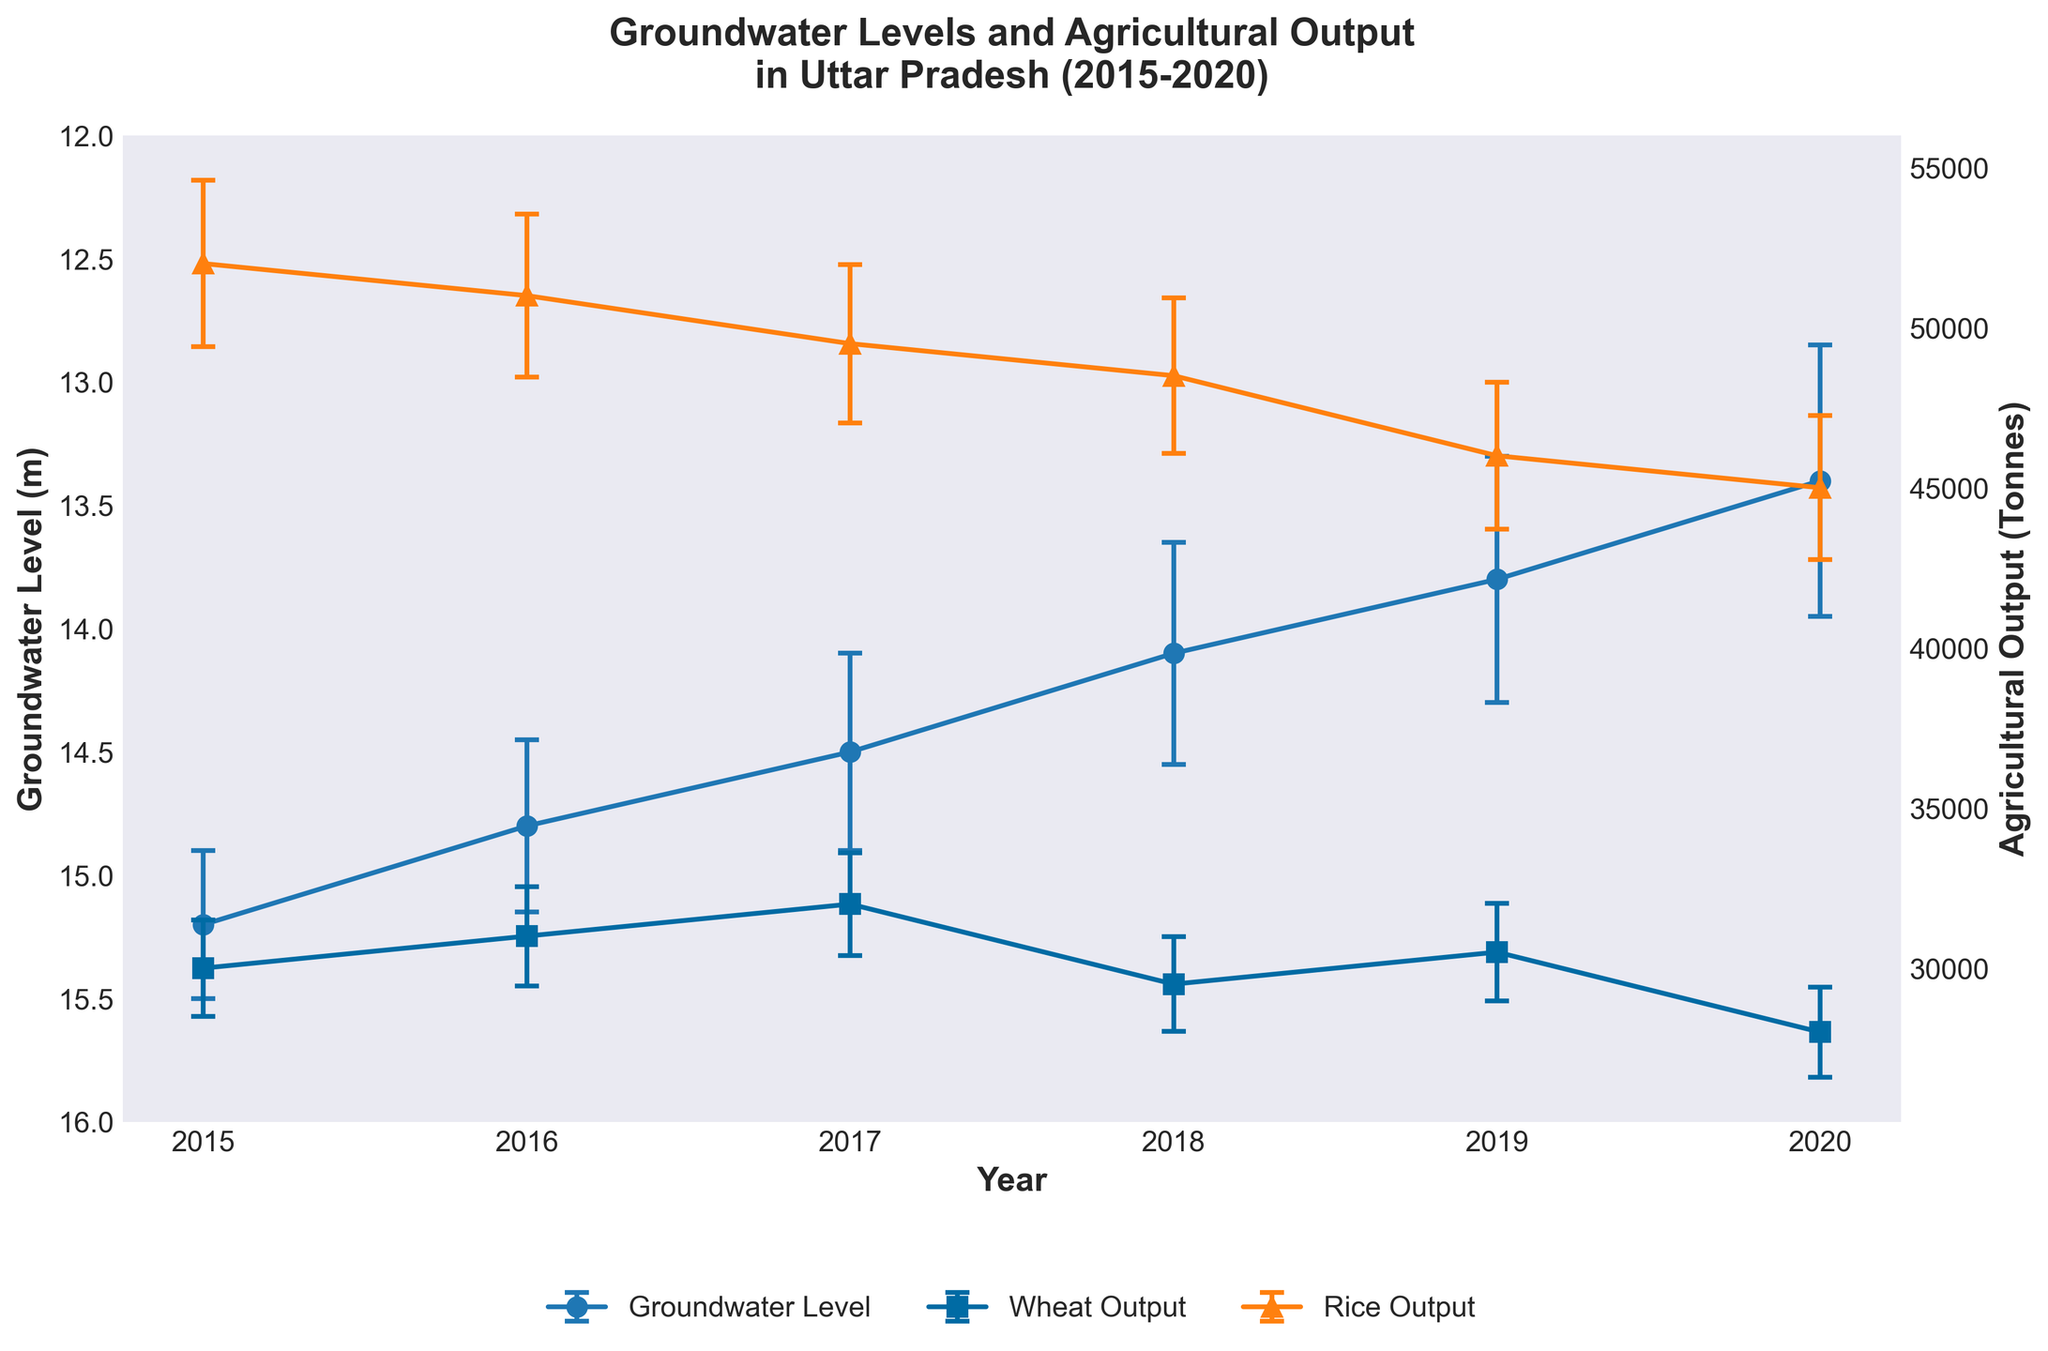what is the title of the figure? The title is located at the top center of the plot and summarizes the entire figure in one sentence. It reads "Groundwater Levels and Agricultural Output in Uttar Pradesh (2015-2020)"
Answer: Groundwater Levels and Agricultural Output in Uttar Pradesh (2015-2020) Between 2015 and 2020, in which year was the groundwater level the lowest? Look at the lowest point in the line representing the groundwater levels on the plot. The year can be identified on the x-axis corresponding to this point.
Answer: 2020 How does the groundwater level trend change over the years from 2015 to 2020? Observe the overall direction of the groundwater level line from the leftmost point (2015) to the rightmost point (2020). The line continuously trends downward.
Answer: Decreasing Is there a notable difference in agricultural output between Wheat and Rice from 2015 to 2020? Compare the two lines representing Wheat and Rice output over the years. While the adjustments in output are minor, Rice consistently yields higher output values than Wheat each year.
Answer: Yes, Rice generally has higher output In which year did Wheat have the highest agricultural output, and what was the output? Identify the highest point on the Wheat output line and trace it back to the x-axis for the year. The Wheat line uses square markers. The highest point occurs in 2017, with 32,000 tonnes.
Answer: 2017, 32,000 tonnes In 2019, how does the output of Rice compare with Wheat? Look at the points for Rice and Wheat in 2019, as shown on the x-axis. Compare their heights, and the values can be read as 46,000 tonnes for Rice and 30,500 tonnes for Wheat. Rice has a higher output.
Answer: Rice higher than Wheat What is the margin of error for groundwater levels in 2017 and how is it represented? Check the length of the error bars above and below the point for groundwater levels in 2017. The value can be read as 0.4m.
Answer: 0.4m During which year did the agricultural output of Rice experience the most significant decline? Observe the Rice output line, noting where the sharpest downward shift occurs between two consecutive years. The largest decline happens between 2019 and 2020.
Answer: 2019 to 2020 Which crop has larger error margins overall for agricultural output, Wheat or Rice? Assess the size of the error bars for Wheat and Rice lines. Rice typically displays slightly larger error bars.
Answer: Rice By how many meters did the groundwater level drop from 2015 to 2020? Calculate the difference between the groundwater level in 2015 and 2020 values (15.2m - 13.4m = 1.8m).
Answer: 1.8m 